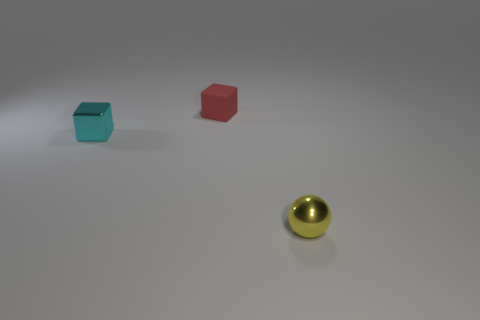There is a tiny cyan object; does it have the same shape as the thing that is behind the small cyan metallic cube?
Your response must be concise. Yes. Are there any metallic things that have the same color as the metallic cube?
Make the answer very short. No. What number of spheres are either small cyan metal things or tiny things?
Offer a very short reply. 1. Is there another metallic object that has the same shape as the yellow metallic thing?
Keep it short and to the point. No. What number of other objects are the same color as the matte block?
Offer a very short reply. 0. Is the number of small cubes to the left of the matte thing less than the number of tiny metallic things?
Offer a very short reply. Yes. How many metallic cubes are there?
Make the answer very short. 1. What number of other tiny cubes have the same material as the tiny red block?
Provide a succinct answer. 0. What number of objects are small things that are in front of the small matte block or cyan cubes?
Your answer should be compact. 2. Are there fewer red matte blocks that are on the left side of the cyan cube than cubes to the left of the matte cube?
Provide a succinct answer. Yes. 